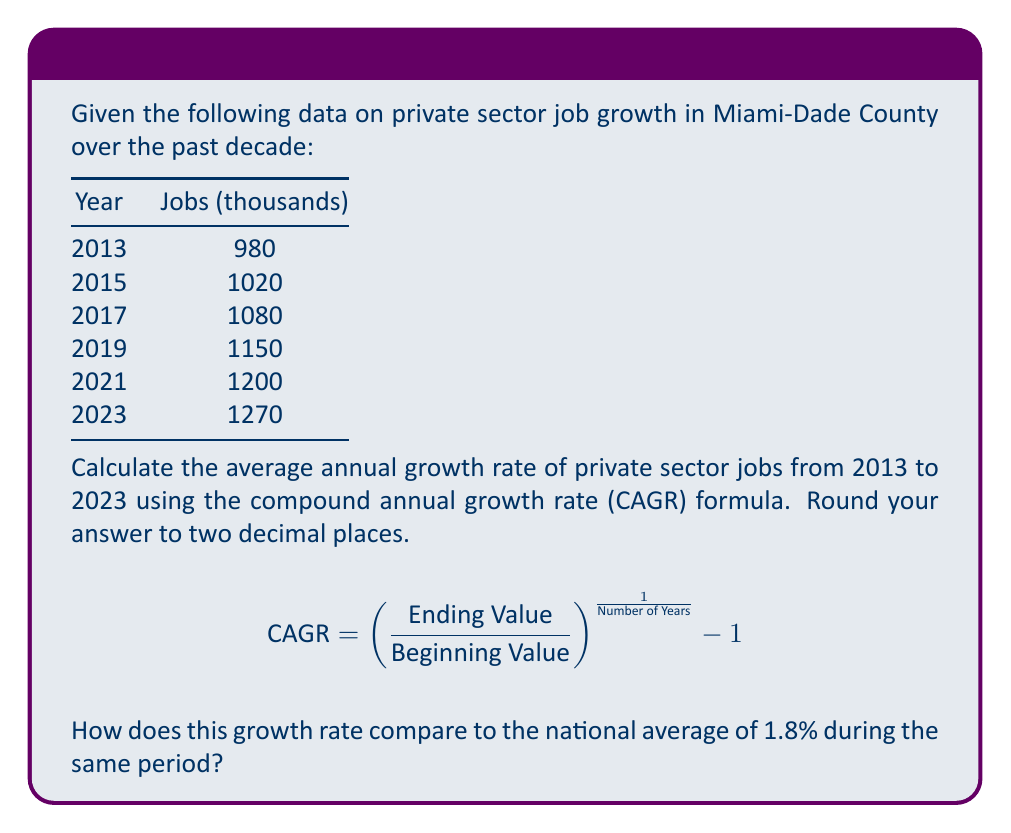Solve this math problem. To solve this problem, we'll follow these steps:

1. Identify the beginning and ending values:
   Beginning Value (2013): 980,000 jobs
   Ending Value (2023): 1,270,000 jobs

2. Calculate the number of years:
   2023 - 2013 = 10 years

3. Apply the CAGR formula:

   $$\text{CAGR} = \left(\frac{1,270,000}{980,000}\right)^{\frac{1}{10}} - 1$$

4. Simplify:
   $$\text{CAGR} = (1.295918367)^{0.1} - 1$$

5. Calculate:
   $$\text{CAGR} = 1.026244 - 1 = 0.026244$$

6. Convert to percentage and round to two decimal places:
   0.026244 * 100 = 2.62%

7. Compare to the national average:
   Miami-Dade County growth rate: 2.62%
   National average: 1.8%
   
   The growth rate in Miami-Dade County is higher than the national average by 0.82 percentage points.
Answer: 2.62%; 0.82 percentage points higher than the national average 